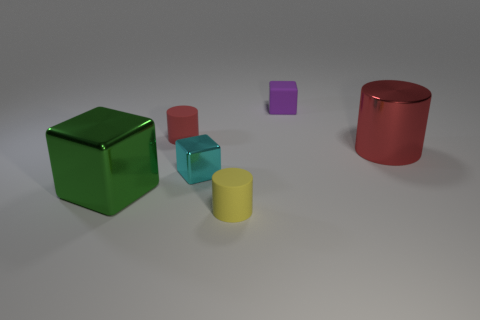Add 2 tiny brown objects. How many objects exist? 8 Subtract all yellow matte things. Subtract all large shiny cylinders. How many objects are left? 4 Add 4 big red metallic objects. How many big red metallic objects are left? 5 Add 4 small blue things. How many small blue things exist? 4 Subtract 0 purple cylinders. How many objects are left? 6 